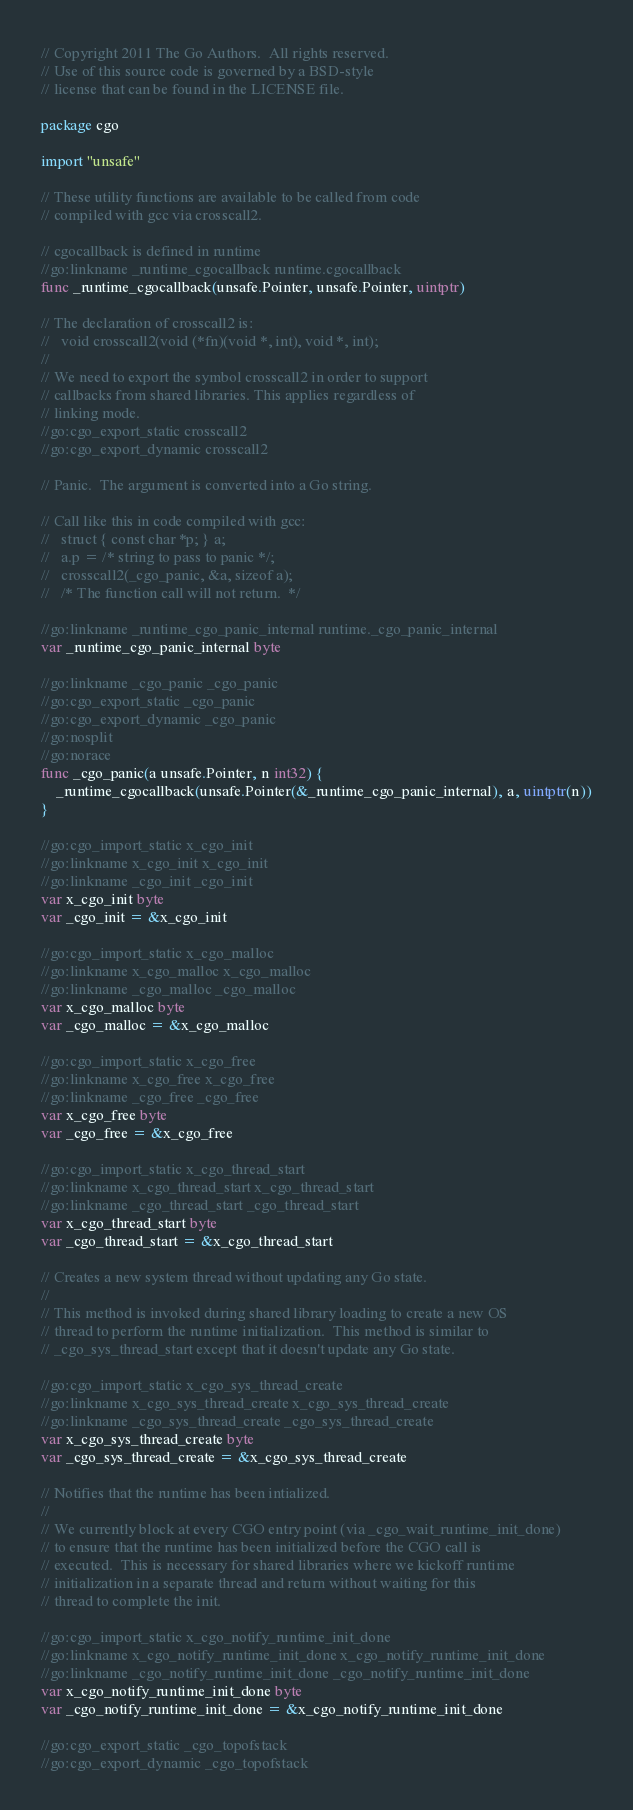<code> <loc_0><loc_0><loc_500><loc_500><_Go_>// Copyright 2011 The Go Authors.  All rights reserved.
// Use of this source code is governed by a BSD-style
// license that can be found in the LICENSE file.

package cgo

import "unsafe"

// These utility functions are available to be called from code
// compiled with gcc via crosscall2.

// cgocallback is defined in runtime
//go:linkname _runtime_cgocallback runtime.cgocallback
func _runtime_cgocallback(unsafe.Pointer, unsafe.Pointer, uintptr)

// The declaration of crosscall2 is:
//   void crosscall2(void (*fn)(void *, int), void *, int);
//
// We need to export the symbol crosscall2 in order to support
// callbacks from shared libraries. This applies regardless of
// linking mode.
//go:cgo_export_static crosscall2
//go:cgo_export_dynamic crosscall2

// Panic.  The argument is converted into a Go string.

// Call like this in code compiled with gcc:
//   struct { const char *p; } a;
//   a.p = /* string to pass to panic */;
//   crosscall2(_cgo_panic, &a, sizeof a);
//   /* The function call will not return.  */

//go:linkname _runtime_cgo_panic_internal runtime._cgo_panic_internal
var _runtime_cgo_panic_internal byte

//go:linkname _cgo_panic _cgo_panic
//go:cgo_export_static _cgo_panic
//go:cgo_export_dynamic _cgo_panic
//go:nosplit
//go:norace
func _cgo_panic(a unsafe.Pointer, n int32) {
	_runtime_cgocallback(unsafe.Pointer(&_runtime_cgo_panic_internal), a, uintptr(n))
}

//go:cgo_import_static x_cgo_init
//go:linkname x_cgo_init x_cgo_init
//go:linkname _cgo_init _cgo_init
var x_cgo_init byte
var _cgo_init = &x_cgo_init

//go:cgo_import_static x_cgo_malloc
//go:linkname x_cgo_malloc x_cgo_malloc
//go:linkname _cgo_malloc _cgo_malloc
var x_cgo_malloc byte
var _cgo_malloc = &x_cgo_malloc

//go:cgo_import_static x_cgo_free
//go:linkname x_cgo_free x_cgo_free
//go:linkname _cgo_free _cgo_free
var x_cgo_free byte
var _cgo_free = &x_cgo_free

//go:cgo_import_static x_cgo_thread_start
//go:linkname x_cgo_thread_start x_cgo_thread_start
//go:linkname _cgo_thread_start _cgo_thread_start
var x_cgo_thread_start byte
var _cgo_thread_start = &x_cgo_thread_start

// Creates a new system thread without updating any Go state.
//
// This method is invoked during shared library loading to create a new OS
// thread to perform the runtime initialization.  This method is similar to
// _cgo_sys_thread_start except that it doesn't update any Go state.

//go:cgo_import_static x_cgo_sys_thread_create
//go:linkname x_cgo_sys_thread_create x_cgo_sys_thread_create
//go:linkname _cgo_sys_thread_create _cgo_sys_thread_create
var x_cgo_sys_thread_create byte
var _cgo_sys_thread_create = &x_cgo_sys_thread_create

// Notifies that the runtime has been intialized.
//
// We currently block at every CGO entry point (via _cgo_wait_runtime_init_done)
// to ensure that the runtime has been initialized before the CGO call is
// executed.  This is necessary for shared libraries where we kickoff runtime
// initialization in a separate thread and return without waiting for this
// thread to complete the init.

//go:cgo_import_static x_cgo_notify_runtime_init_done
//go:linkname x_cgo_notify_runtime_init_done x_cgo_notify_runtime_init_done
//go:linkname _cgo_notify_runtime_init_done _cgo_notify_runtime_init_done
var x_cgo_notify_runtime_init_done byte
var _cgo_notify_runtime_init_done = &x_cgo_notify_runtime_init_done

//go:cgo_export_static _cgo_topofstack
//go:cgo_export_dynamic _cgo_topofstack
</code> 